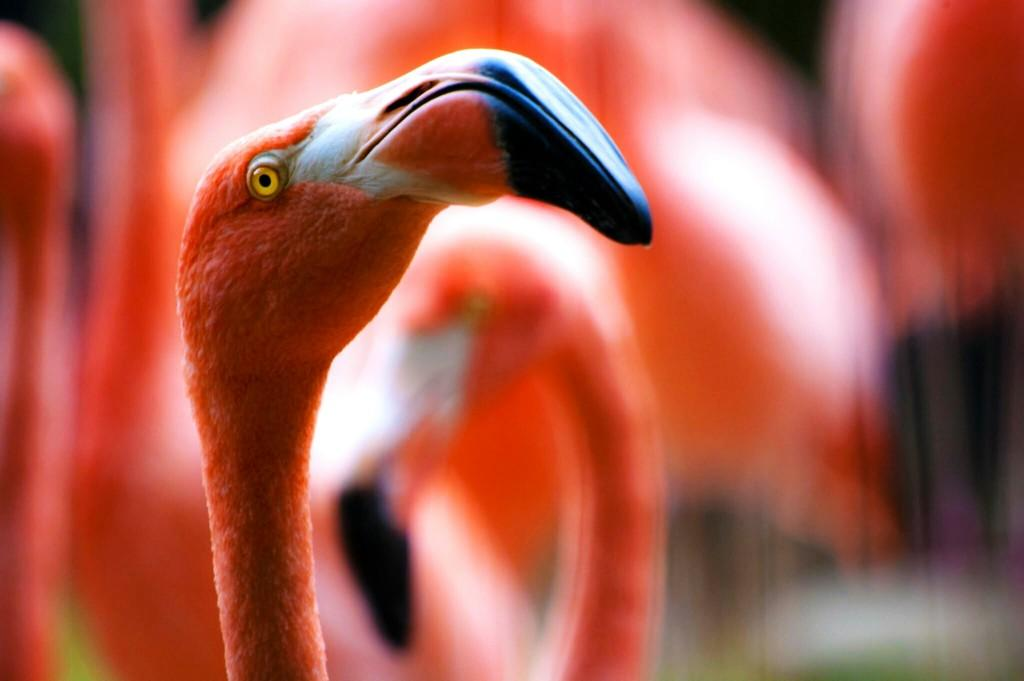What is the main subject of the image? The main subject of the image is a flamingo's head. Are there any other flamingos visible in the image? Yes, there are other flamingos standing in the image. Can you describe the background of the image? The background of the image is blurred. What letters are written on the flamingo's head in the image? There are no letters written on the flamingo's head in the image. What type of toothpaste is used by the flamingos in the image? There is no toothpaste present in the image, as it features flamingos. 